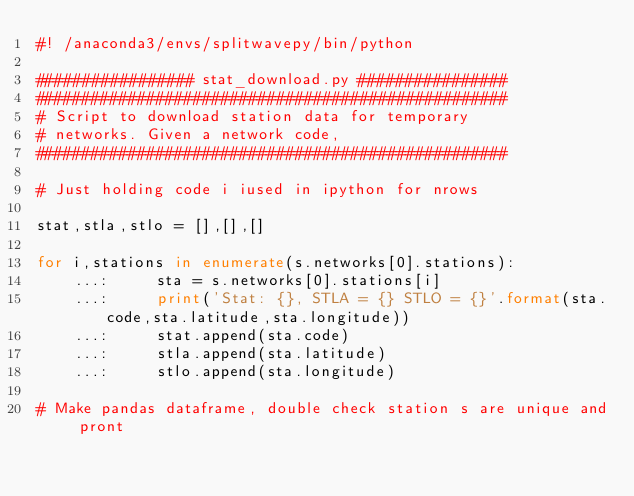<code> <loc_0><loc_0><loc_500><loc_500><_Python_>#! /anaconda3/envs/splitwavepy/bin/python

################# stat_download.py ################
###################################################
# Script to download station data for temporary
# networks. Given a network code,
###################################################

# Just holding code i iused in ipython for nrows

stat,stla,stlo = [],[],[]

for i,stations in enumerate(s.networks[0].stations):
    ...:     sta = s.networks[0].stations[i]
    ...:     print('Stat: {}, STLA = {} STLO = {}'.format(sta.code,sta.latitude,sta.longitude))
    ...:     stat.append(sta.code)
    ...:     stla.append(sta.latitude)
    ...:     stlo.append(sta.longitude)

# Make pandas dataframe, double check station s are unique and pront 
</code> 